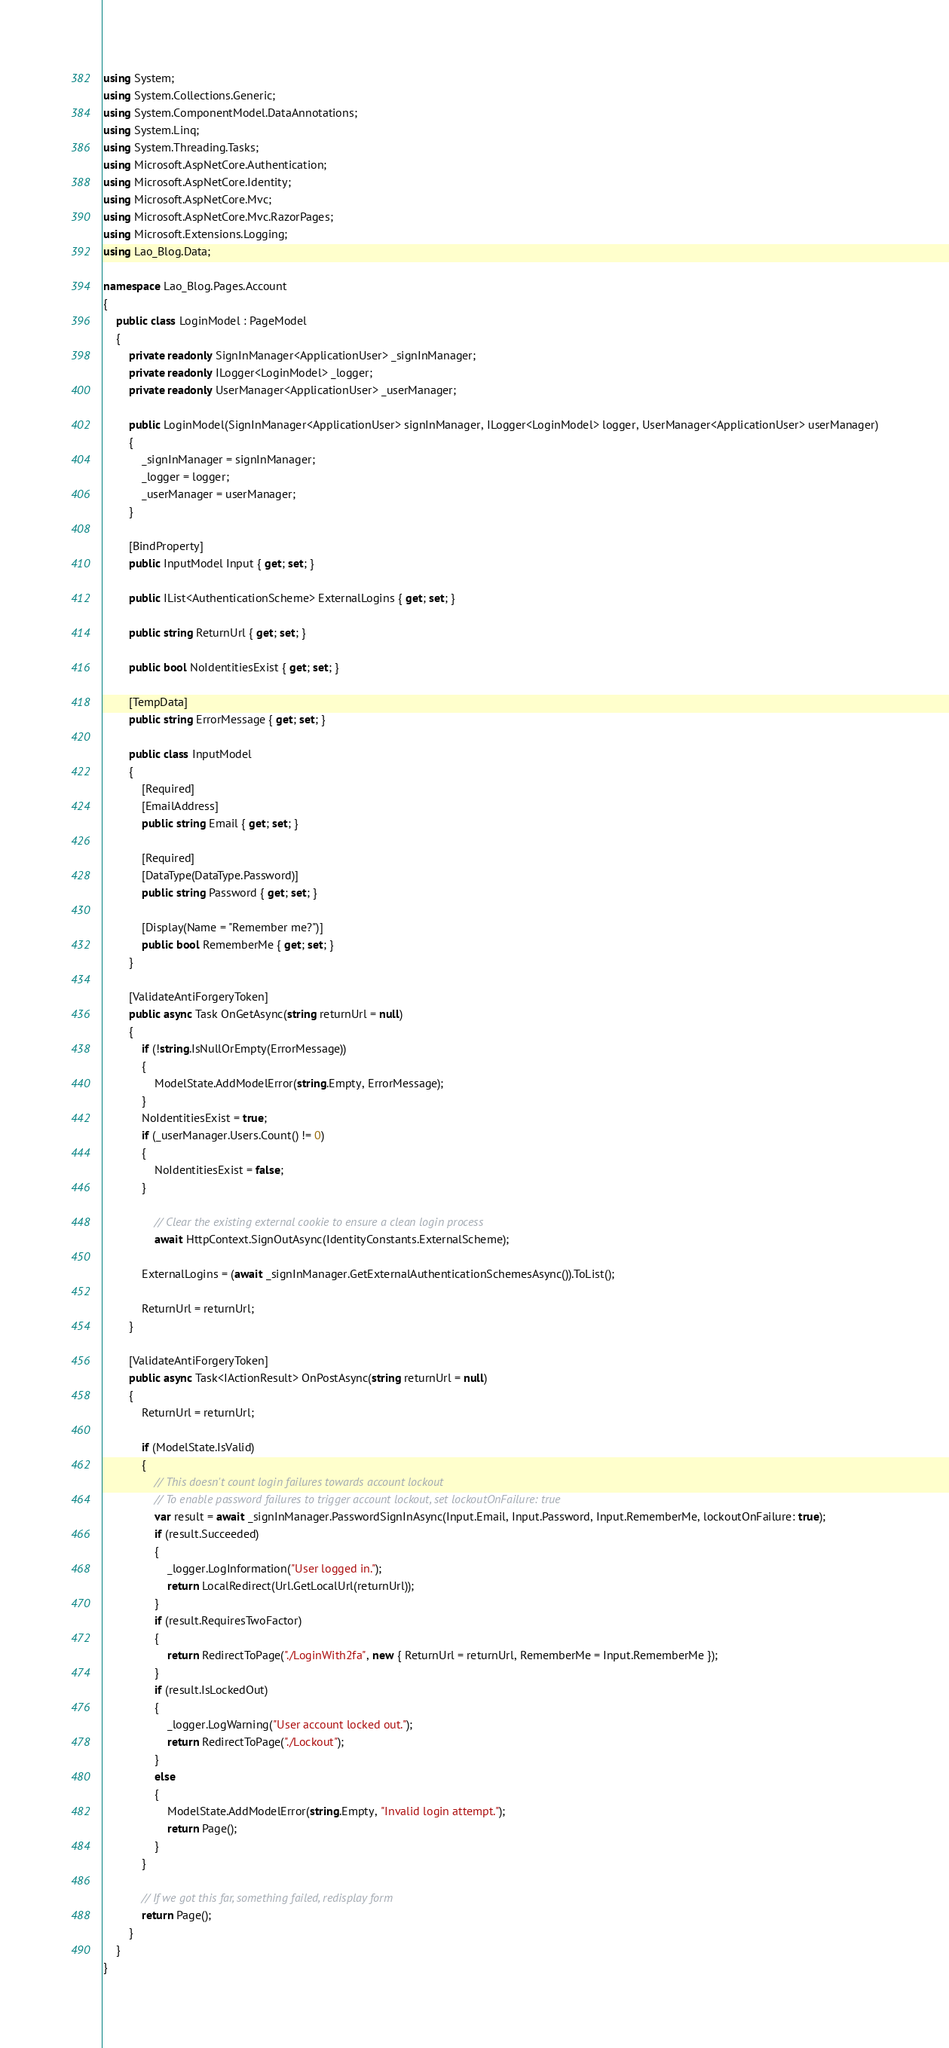Convert code to text. <code><loc_0><loc_0><loc_500><loc_500><_C#_>using System;
using System.Collections.Generic;
using System.ComponentModel.DataAnnotations;
using System.Linq;
using System.Threading.Tasks;
using Microsoft.AspNetCore.Authentication;
using Microsoft.AspNetCore.Identity;
using Microsoft.AspNetCore.Mvc;
using Microsoft.AspNetCore.Mvc.RazorPages;
using Microsoft.Extensions.Logging;
using Lao_Blog.Data;

namespace Lao_Blog.Pages.Account
{
    public class LoginModel : PageModel
    {
        private readonly SignInManager<ApplicationUser> _signInManager;
        private readonly ILogger<LoginModel> _logger;
        private readonly UserManager<ApplicationUser> _userManager;

        public LoginModel(SignInManager<ApplicationUser> signInManager, ILogger<LoginModel> logger, UserManager<ApplicationUser> userManager)
        {
            _signInManager = signInManager;
            _logger = logger;
            _userManager = userManager;
        }

        [BindProperty]
        public InputModel Input { get; set; }

        public IList<AuthenticationScheme> ExternalLogins { get; set; }

        public string ReturnUrl { get; set; }

        public bool NoIdentitiesExist { get; set; }

        [TempData]
        public string ErrorMessage { get; set; }

        public class InputModel
        {
            [Required]
            [EmailAddress]
            public string Email { get; set; }

            [Required]
            [DataType(DataType.Password)]
            public string Password { get; set; }

            [Display(Name = "Remember me?")]
            public bool RememberMe { get; set; }
        }

        [ValidateAntiForgeryToken]
        public async Task OnGetAsync(string returnUrl = null)
        {
            if (!string.IsNullOrEmpty(ErrorMessage))
            {
                ModelState.AddModelError(string.Empty, ErrorMessage);
            }
            NoIdentitiesExist = true;
            if (_userManager.Users.Count() != 0)
            {
                NoIdentitiesExist = false;
            }

                // Clear the existing external cookie to ensure a clean login process
                await HttpContext.SignOutAsync(IdentityConstants.ExternalScheme);

            ExternalLogins = (await _signInManager.GetExternalAuthenticationSchemesAsync()).ToList();

            ReturnUrl = returnUrl;
        }

        [ValidateAntiForgeryToken]
        public async Task<IActionResult> OnPostAsync(string returnUrl = null)
        {
            ReturnUrl = returnUrl;

            if (ModelState.IsValid)
            {
                // This doesn't count login failures towards account lockout
                // To enable password failures to trigger account lockout, set lockoutOnFailure: true
                var result = await _signInManager.PasswordSignInAsync(Input.Email, Input.Password, Input.RememberMe, lockoutOnFailure: true);
                if (result.Succeeded)
                {
                    _logger.LogInformation("User logged in.");
                    return LocalRedirect(Url.GetLocalUrl(returnUrl));
                }
                if (result.RequiresTwoFactor)
                {
                    return RedirectToPage("./LoginWith2fa", new { ReturnUrl = returnUrl, RememberMe = Input.RememberMe });
                }
                if (result.IsLockedOut)
                {
                    _logger.LogWarning("User account locked out.");
                    return RedirectToPage("./Lockout");
                }
                else
                {
                    ModelState.AddModelError(string.Empty, "Invalid login attempt.");
                    return Page();
                }
            }

            // If we got this far, something failed, redisplay form
            return Page();
        }
    }
}
</code> 